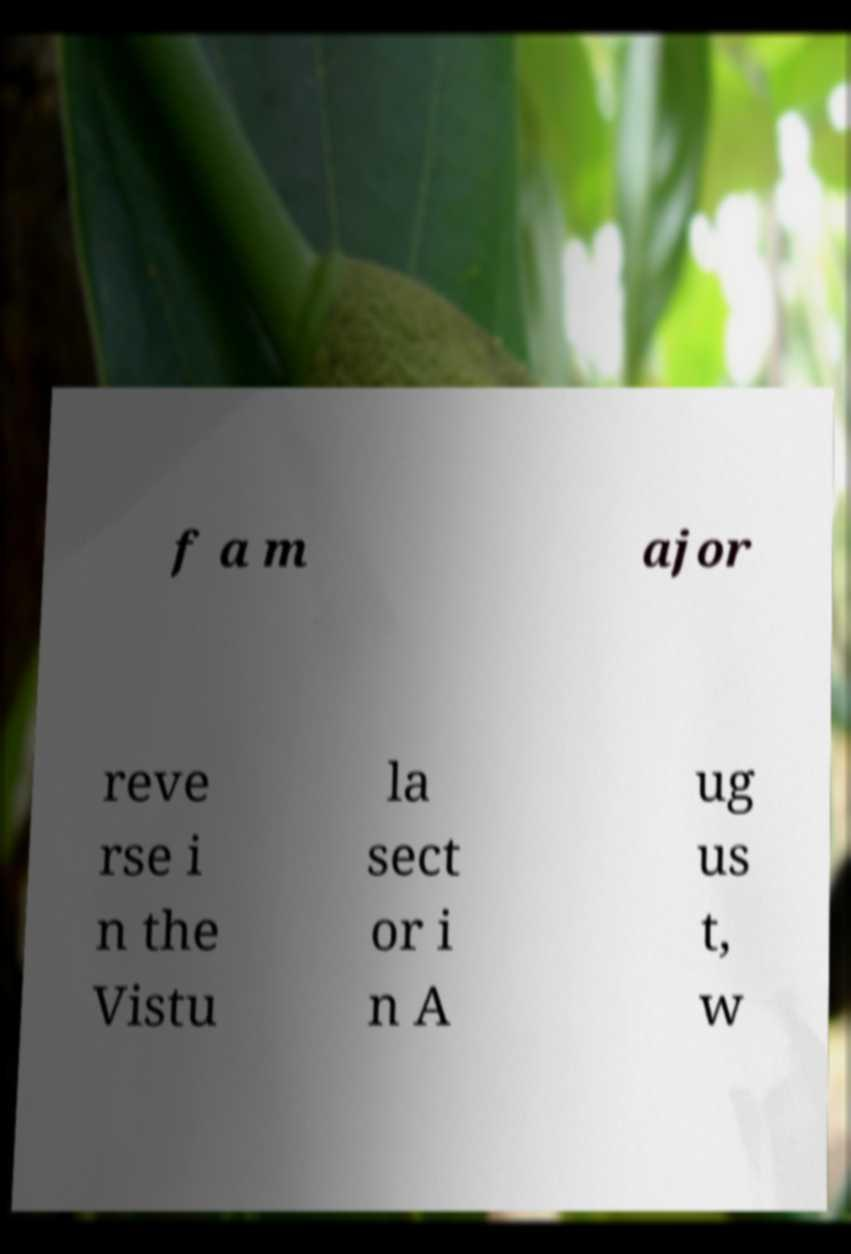There's text embedded in this image that I need extracted. Can you transcribe it verbatim? f a m ajor reve rse i n the Vistu la sect or i n A ug us t, w 